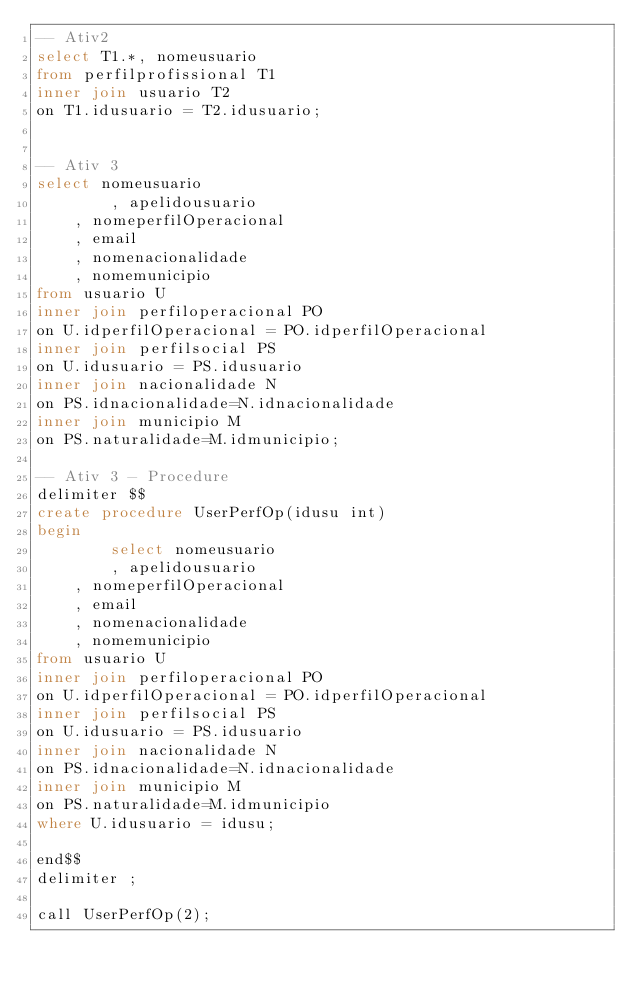Convert code to text. <code><loc_0><loc_0><loc_500><loc_500><_SQL_>-- Ativ2
select T1.*, nomeusuario
from perfilprofissional T1
inner join usuario T2
on T1.idusuario = T2.idusuario;


-- Ativ 3
select nomeusuario
        , apelidousuario
    , nomeperfilOperacional
    , email
    , nomenacionalidade
    , nomemunicipio
from usuario U
inner join perfiloperacional PO
on U.idperfilOperacional = PO.idperfilOperacional
inner join perfilsocial PS
on U.idusuario = PS.idusuario
inner join nacionalidade N 
on PS.idnacionalidade=N.idnacionalidade
inner join municipio M
on PS.naturalidade=M.idmunicipio;

-- Ativ 3 - Procedure
delimiter $$
create procedure UserPerfOp(idusu int)
begin
        select nomeusuario
        , apelidousuario
    , nomeperfilOperacional
    , email
    , nomenacionalidade
    , nomemunicipio
from usuario U
inner join perfiloperacional PO
on U.idperfilOperacional = PO.idperfilOperacional
inner join perfilsocial PS
on U.idusuario = PS.idusuario
inner join nacionalidade N 
on PS.idnacionalidade=N.idnacionalidade
inner join municipio M
on PS.naturalidade=M.idmunicipio
where U.idusuario = idusu;

end$$
delimiter ;

call UserPerfOp(2);


</code> 